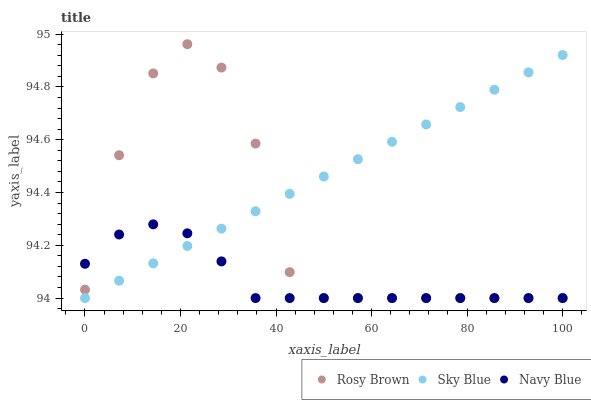Does Navy Blue have the minimum area under the curve?
Answer yes or no. Yes. Does Sky Blue have the maximum area under the curve?
Answer yes or no. Yes. Does Rosy Brown have the minimum area under the curve?
Answer yes or no. No. Does Rosy Brown have the maximum area under the curve?
Answer yes or no. No. Is Sky Blue the smoothest?
Answer yes or no. Yes. Is Rosy Brown the roughest?
Answer yes or no. Yes. Is Navy Blue the smoothest?
Answer yes or no. No. Is Navy Blue the roughest?
Answer yes or no. No. Does Sky Blue have the lowest value?
Answer yes or no. Yes. Does Rosy Brown have the highest value?
Answer yes or no. Yes. Does Navy Blue have the highest value?
Answer yes or no. No. Does Sky Blue intersect Rosy Brown?
Answer yes or no. Yes. Is Sky Blue less than Rosy Brown?
Answer yes or no. No. Is Sky Blue greater than Rosy Brown?
Answer yes or no. No. 